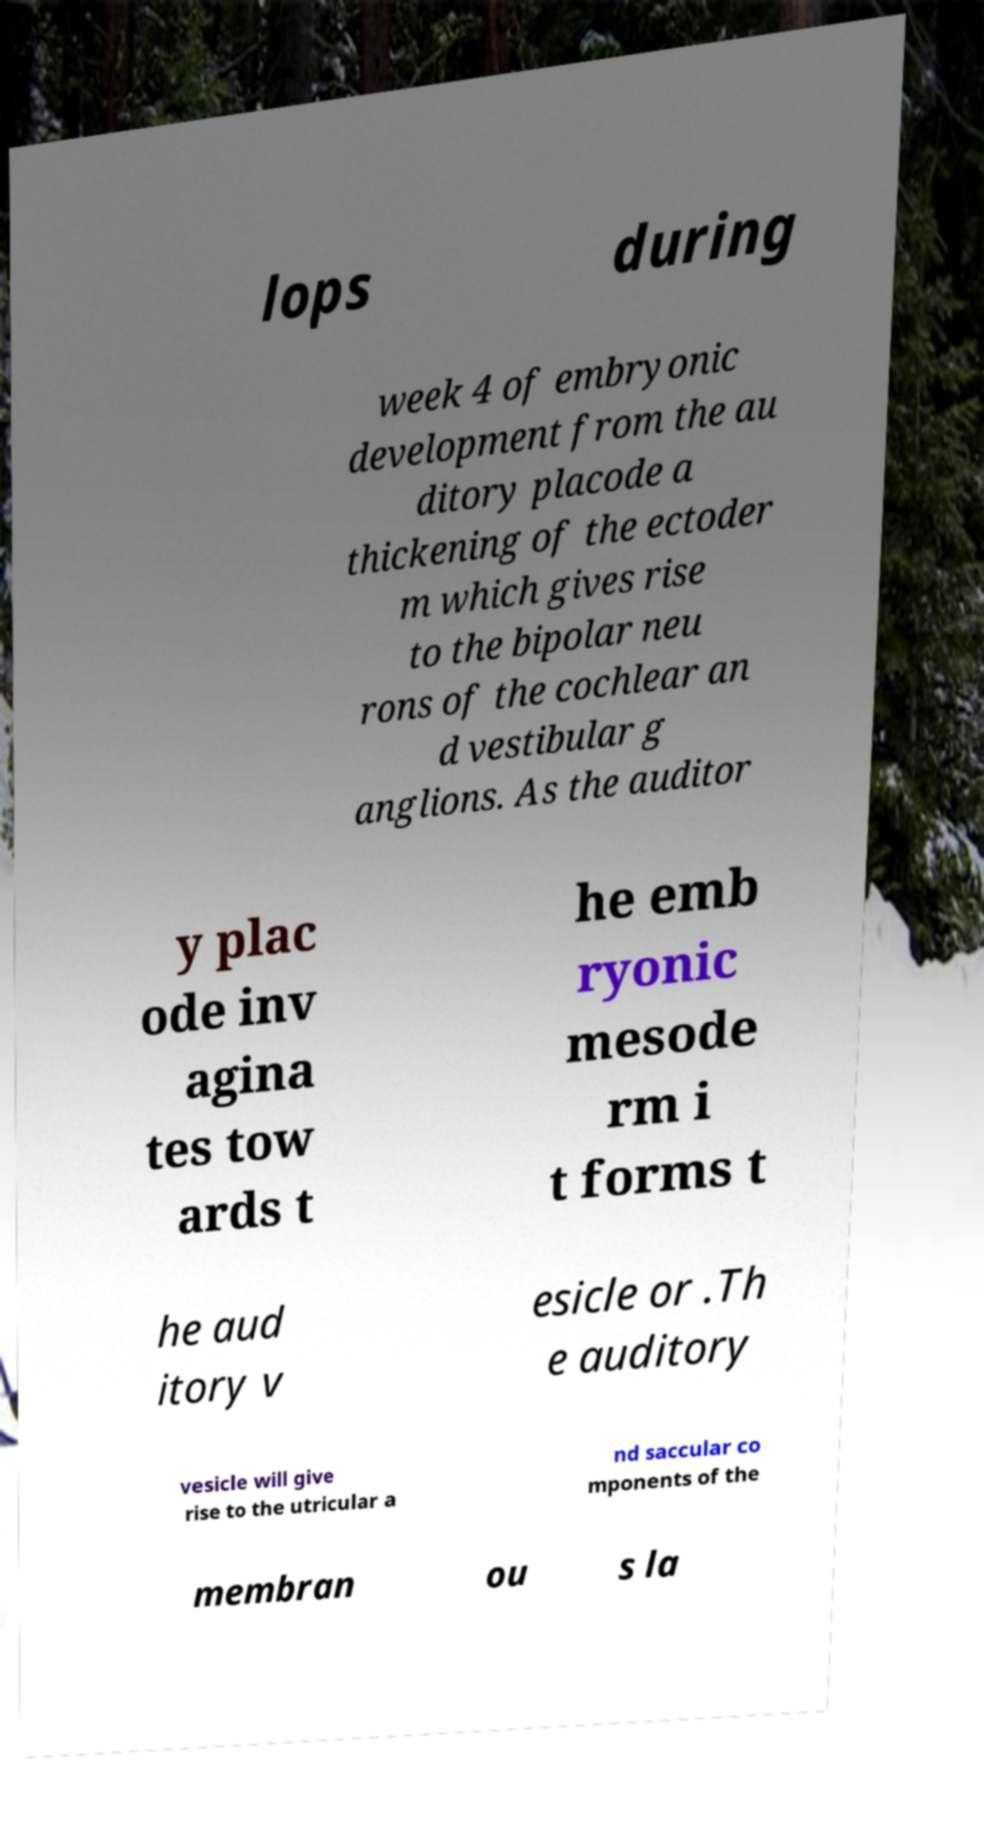Can you accurately transcribe the text from the provided image for me? lops during week 4 of embryonic development from the au ditory placode a thickening of the ectoder m which gives rise to the bipolar neu rons of the cochlear an d vestibular g anglions. As the auditor y plac ode inv agina tes tow ards t he emb ryonic mesode rm i t forms t he aud itory v esicle or .Th e auditory vesicle will give rise to the utricular a nd saccular co mponents of the membran ou s la 